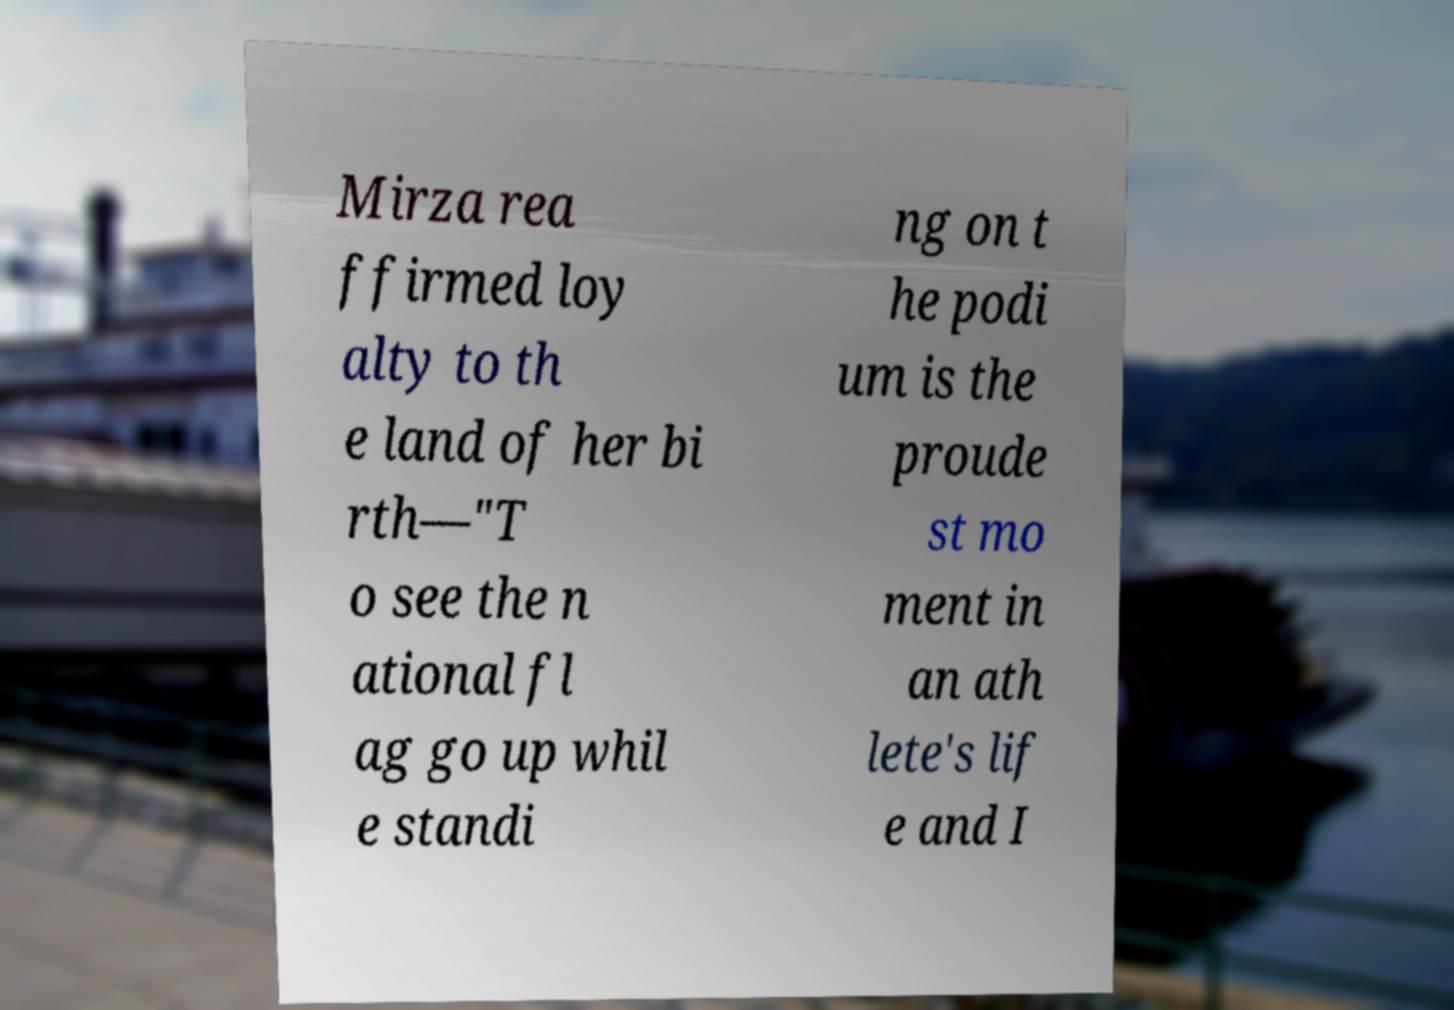Please identify and transcribe the text found in this image. Mirza rea ffirmed loy alty to th e land of her bi rth—"T o see the n ational fl ag go up whil e standi ng on t he podi um is the proude st mo ment in an ath lete's lif e and I 